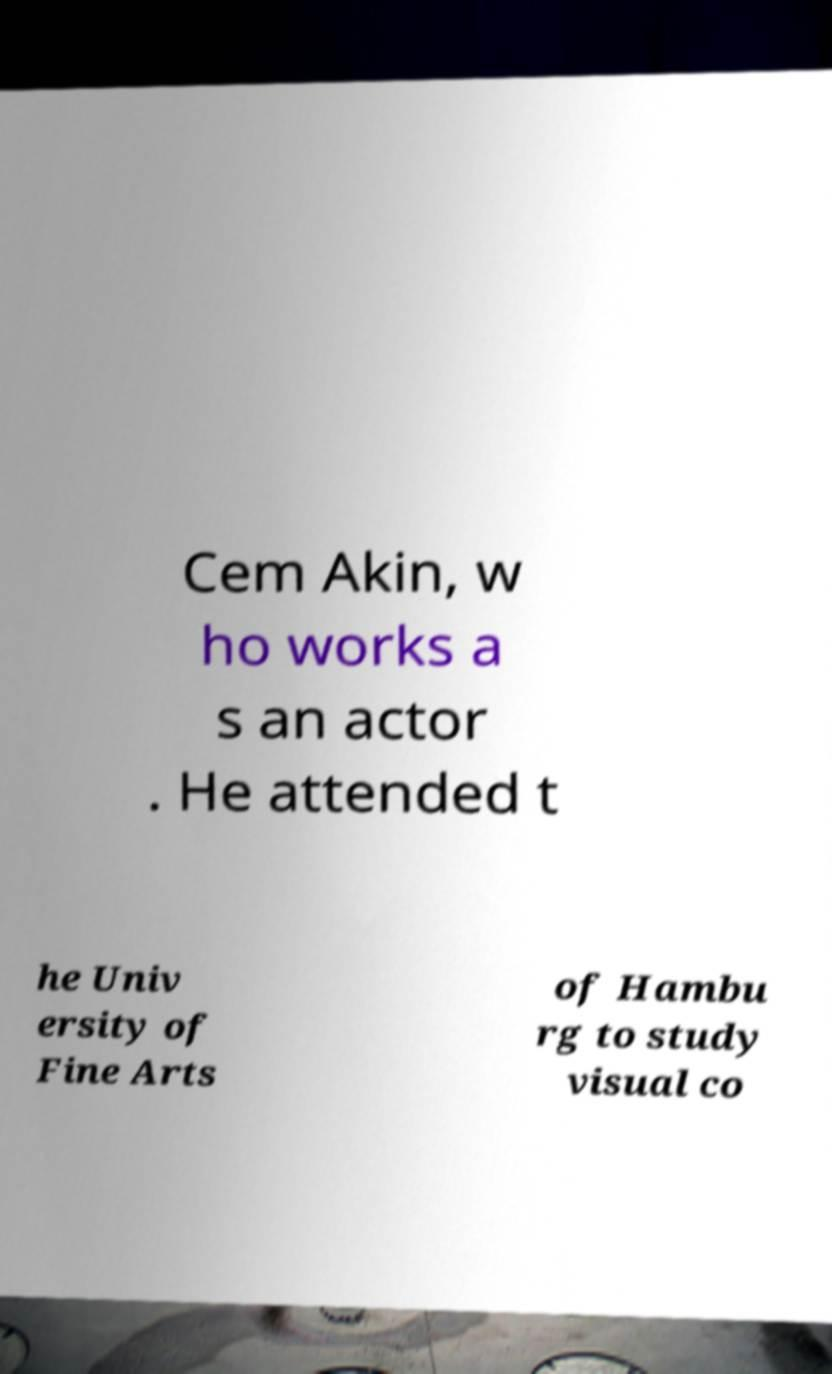I need the written content from this picture converted into text. Can you do that? Cem Akin, w ho works a s an actor . He attended t he Univ ersity of Fine Arts of Hambu rg to study visual co 